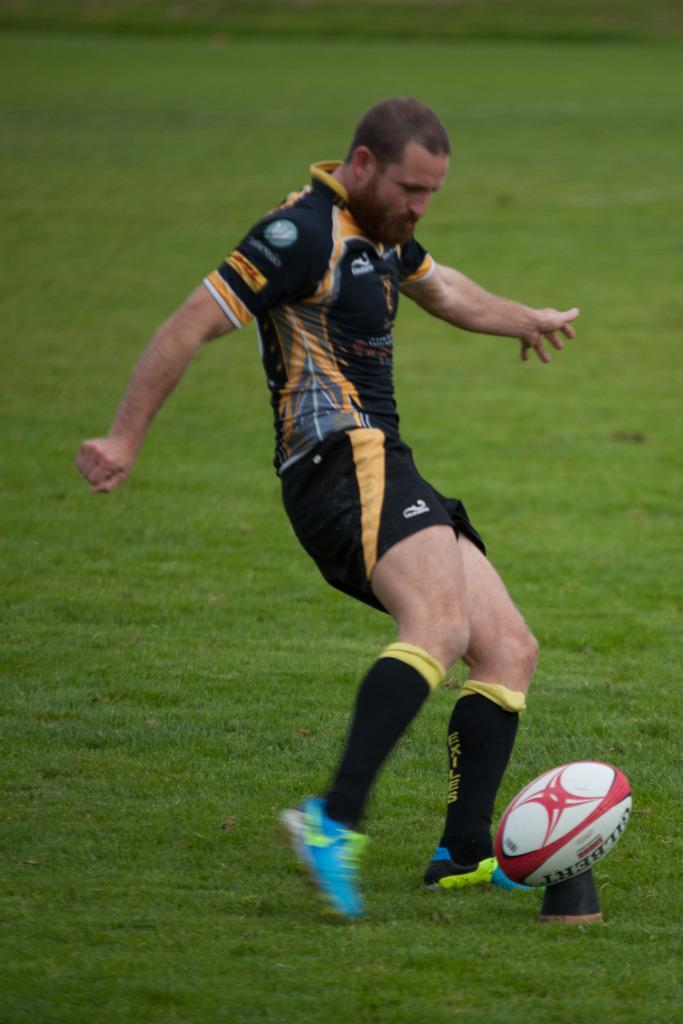What is the main subject of the image? There is a person in the image. What is the person doing in the image? The person is kicking a rugby ball. Can you describe the position of the rugby ball in the image? The rugby ball is on the ground. What type of insect can be seen crawling on the linen in the image? There is no insect or linen present in the image; it features a person kicking a rugby ball. 